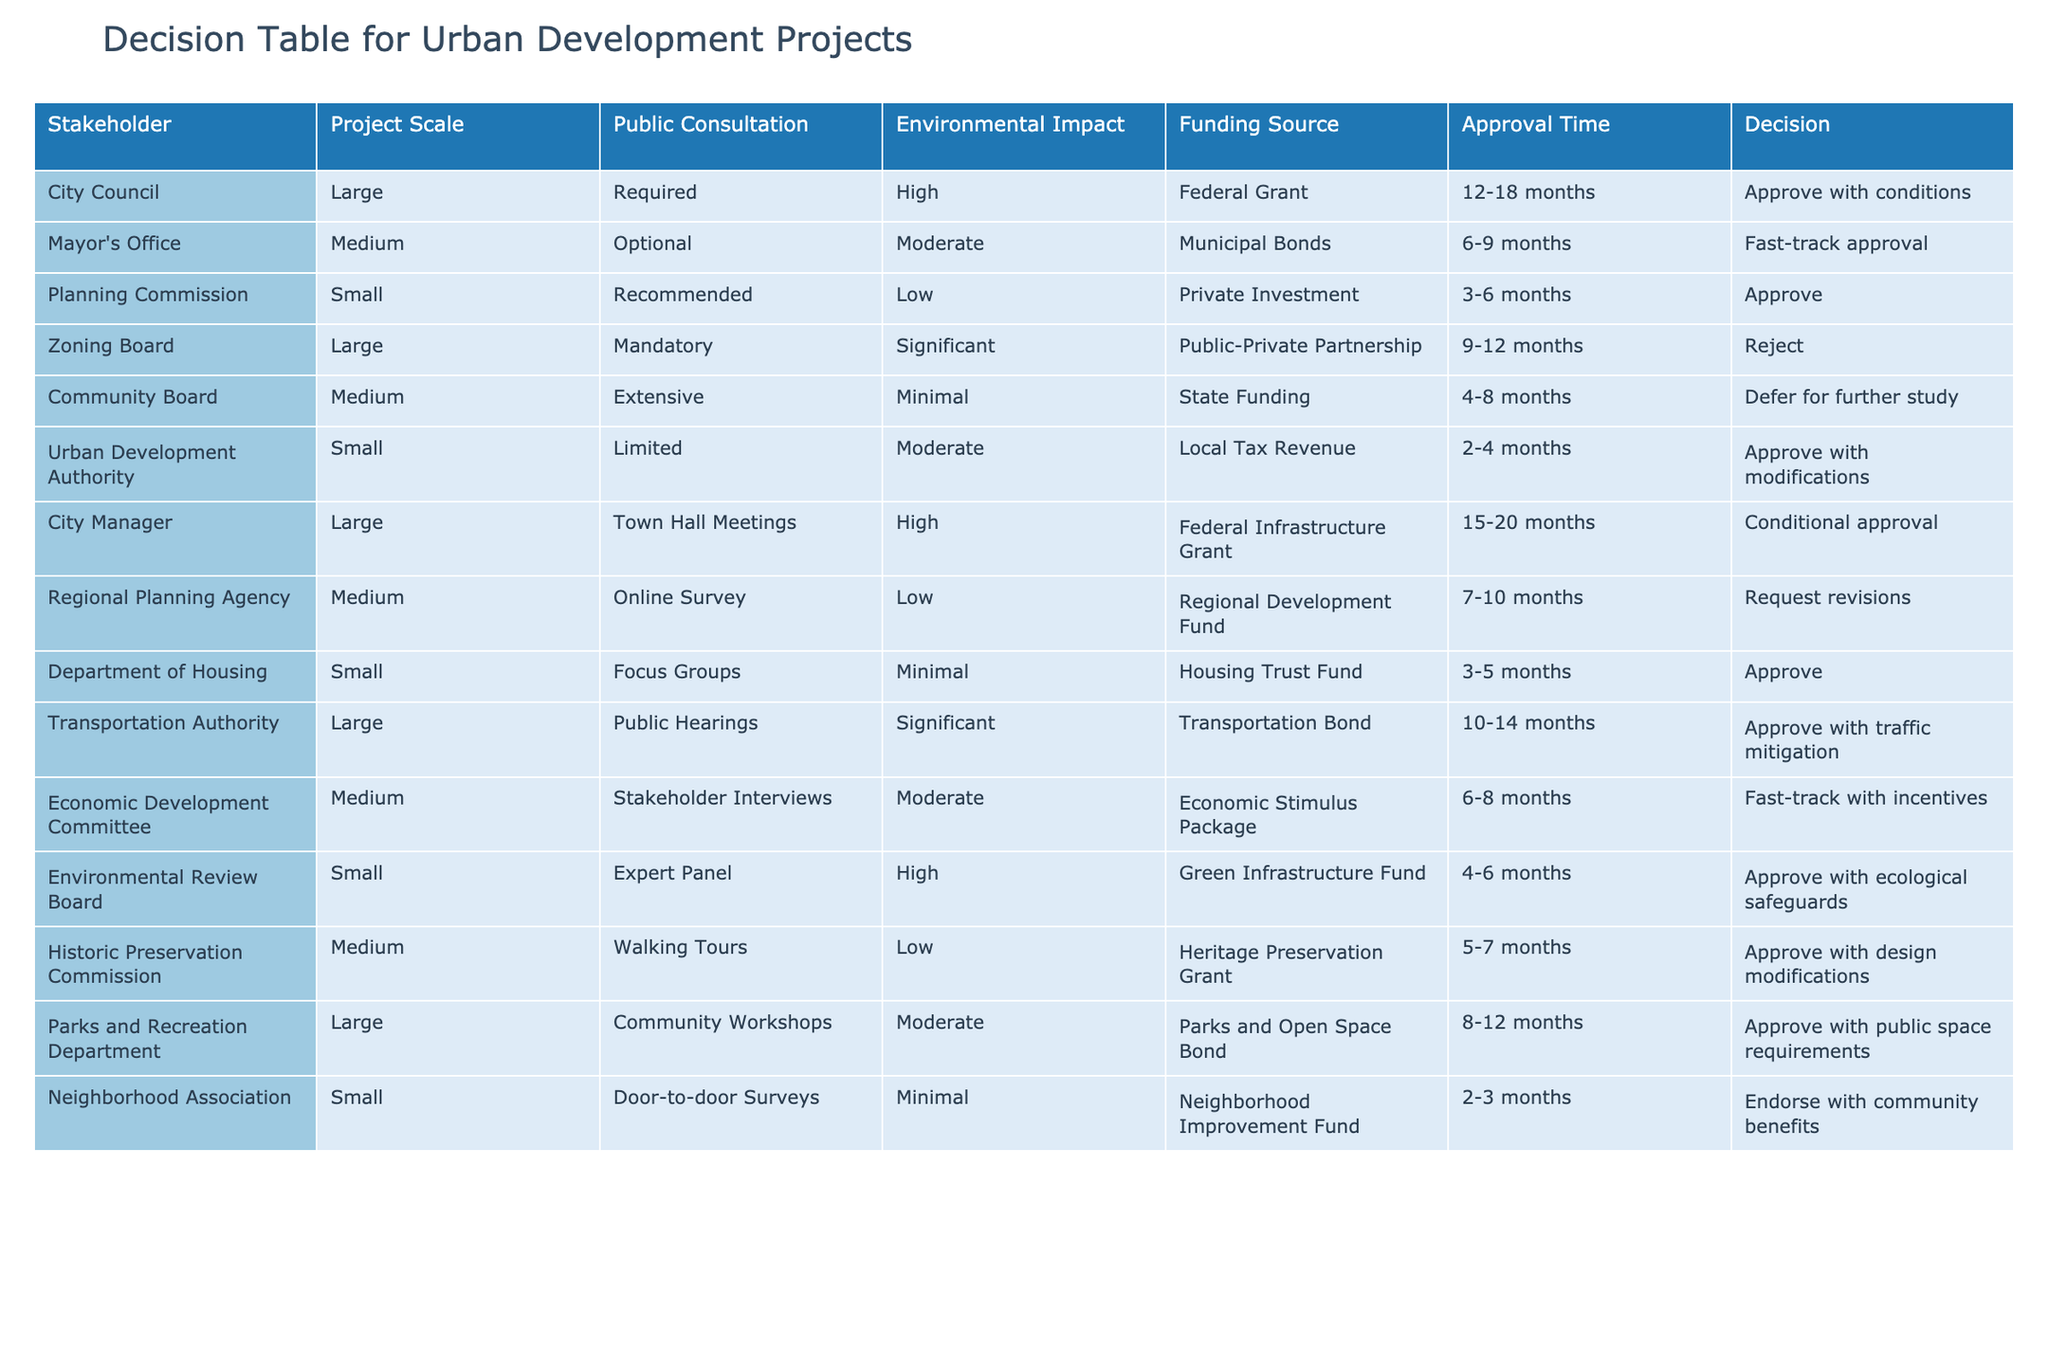What is the decision of the Planning Commission for small projects? According to the table, the Planning Commission approves small projects. This information can be directly found in the decision column corresponding to the Planning Commission row.
Answer: Approve What is the funding source for the City Council's large projects? The funding source for the City Council's large projects can be found in the table under the funding source column for the City Council row, which lists it as Federal Grant.
Answer: Federal Grant How many months does it take on average for approvals from the Transportation Authority and the Mayor's Office for large projects? The approval time for the Transportation Authority is between 10-14 months, which averages to 12 months. The Mayor's Office takes 6-9 months, averaging 7.5 months. Therefore, the combined average is (12 + 7.5)/2 = 9.75 months.
Answer: 9.75 months Does the Community Board require public consultation for medium-sized projects? The table shows that the Community Board has extensive public consultation for medium-sized projects, which indicates that public consultation is indeed required.
Answer: Yes Which board has the longest estimated approval time for large projects? The City Manager has the longest approval time for large projects, which is between 15-20 months. This can be determined by comparing the approval time columns in the rows of different boards for large projects.
Answer: City Manager What is the most common type of funding source for small urban development projects listed in the table? By examining the funding source column for all small projects, we find that Housing Trust Fund is listed for the Department of Housing, while other entries mention different funds. Thus, it can be indicated that Housing Trust Fund is common.
Answer: Housing Trust Fund How many boards require mandatory public consultation for large urban development projects? The table shows two boards that require mandatory public consultation for large projects: the Zoning Board and City Manager's office. Counting these entries gives the total.
Answer: Two What percentage of medium-sized projects is fast-tracked by either the Mayor's Office or the Economic Development Committee? There are three medium-sized projects total. The Mayor's Office fast-tracks projects as does the Economic Development Committee. Therefore, 2 out of 3 projects are fast-tracked, which is (2/3)x100 = 66.67%.
Answer: 66.67% 